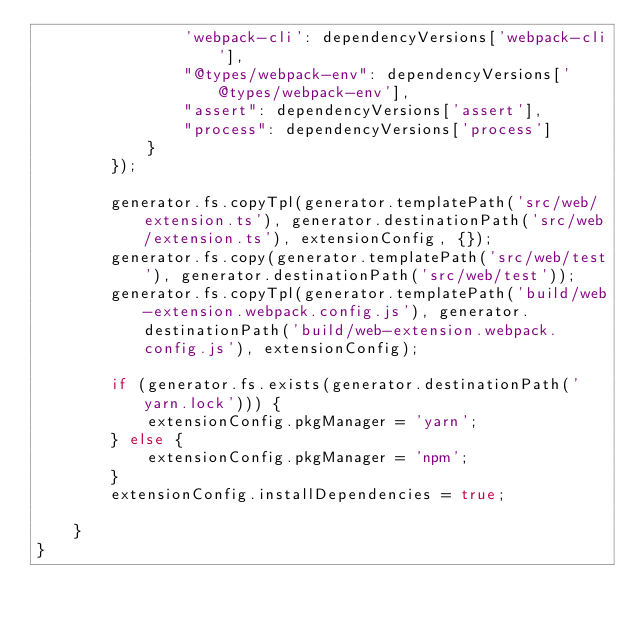Convert code to text. <code><loc_0><loc_0><loc_500><loc_500><_JavaScript_>                'webpack-cli': dependencyVersions['webpack-cli'],
                "@types/webpack-env": dependencyVersions['@types/webpack-env'],
                "assert": dependencyVersions['assert'],
                "process": dependencyVersions['process']
            }
        });

        generator.fs.copyTpl(generator.templatePath('src/web/extension.ts'), generator.destinationPath('src/web/extension.ts'), extensionConfig, {});
        generator.fs.copy(generator.templatePath('src/web/test'), generator.destinationPath('src/web/test'));
        generator.fs.copyTpl(generator.templatePath('build/web-extension.webpack.config.js'), generator.destinationPath('build/web-extension.webpack.config.js'), extensionConfig);

        if (generator.fs.exists(generator.destinationPath('yarn.lock'))) {
            extensionConfig.pkgManager = 'yarn';
        } else {
            extensionConfig.pkgManager = 'npm';
        }
        extensionConfig.installDependencies = true;

    }
}
</code> 